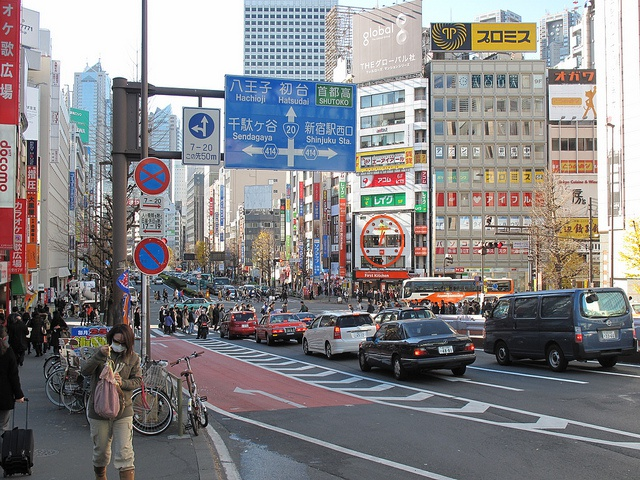Describe the objects in this image and their specific colors. I can see people in brown, gray, black, darkgray, and lightgray tones, truck in brown, black, gray, and darkgray tones, people in brown, gray, and black tones, car in brown, black, gray, blue, and darkgray tones, and car in brown, black, darkgray, gray, and lightgray tones in this image. 